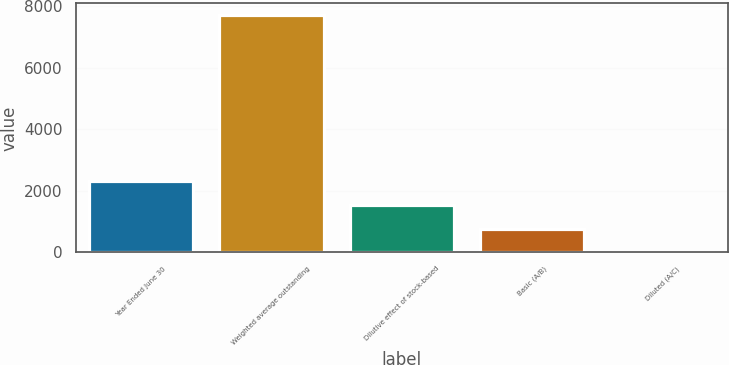Convert chart to OTSL. <chart><loc_0><loc_0><loc_500><loc_500><bar_chart><fcel>Year Ended June 30<fcel>Weighted average outstanding<fcel>Dilutive effect of stock-based<fcel>Basic (A/B)<fcel>Diluted (A/C)<nl><fcel>2311.5<fcel>7700<fcel>1541.71<fcel>771.92<fcel>2.13<nl></chart> 